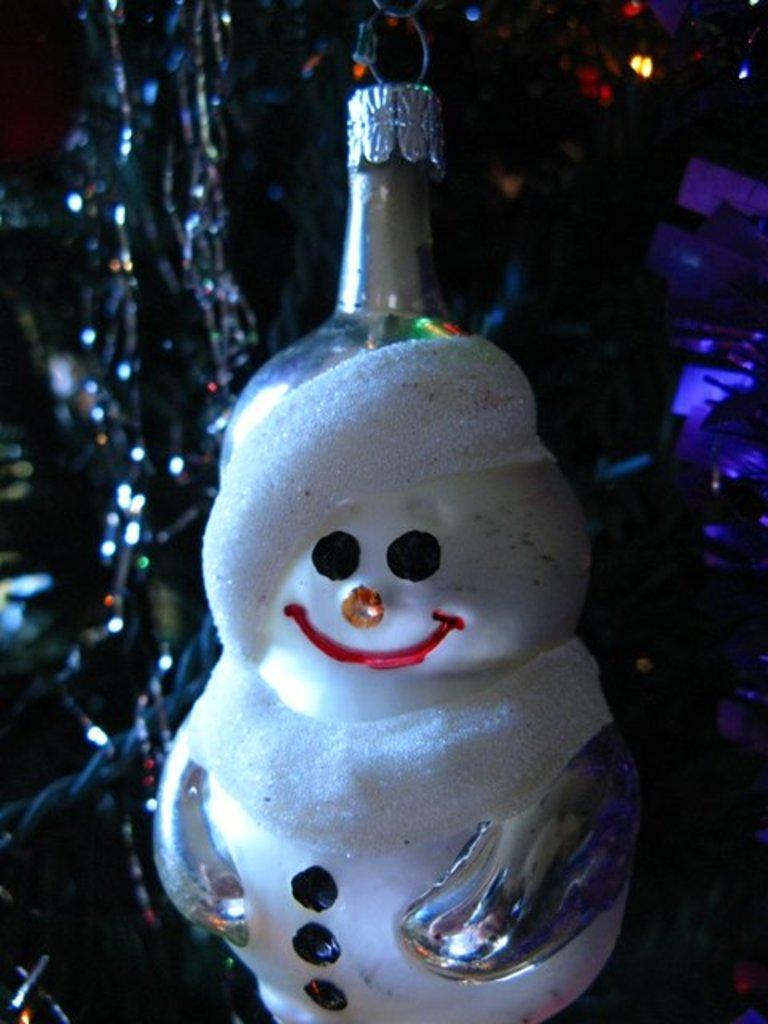In one or two sentences, can you explain what this image depicts? Here we can see a bottle with a toy structure on it. In the background the image is not clear but we can see lights and other objects. 